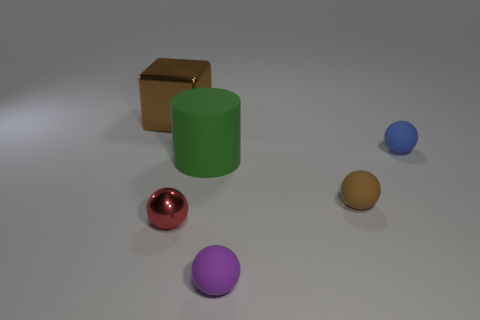How many objects are either big purple blocks or green matte cylinders?
Provide a short and direct response. 1. Is there a brown matte object of the same shape as the small purple matte object?
Your answer should be compact. Yes. The big thing that is behind the rubber thing that is to the right of the tiny brown ball is what shape?
Offer a terse response. Cube. Is there a cylinder that has the same size as the brown metallic cube?
Provide a short and direct response. Yes. Are there fewer red shiny balls than gray metallic balls?
Your answer should be very brief. No. There is a shiny thing right of the thing behind the tiny thing that is behind the big matte thing; what shape is it?
Your response must be concise. Sphere. How many things are either spheres that are in front of the cylinder or large things that are on the right side of the large brown shiny object?
Make the answer very short. 4. Are there any metal cubes in front of the large green thing?
Your answer should be very brief. No. How many things are small things in front of the blue rubber thing or small brown rubber objects?
Provide a short and direct response. 3. How many yellow objects are either tiny cubes or tiny matte balls?
Make the answer very short. 0. 